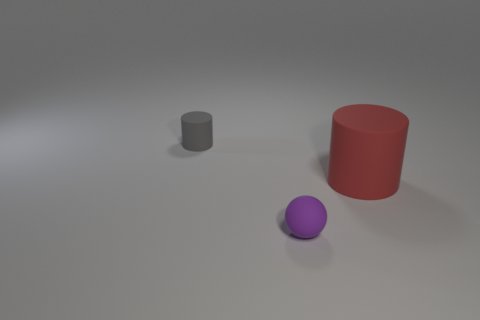Are there fewer big gray cylinders than matte balls?
Your response must be concise. Yes. Is the material of the tiny object left of the sphere the same as the large cylinder?
Give a very brief answer. Yes. How many cylinders are purple rubber things or big red objects?
Give a very brief answer. 1. There is a rubber object that is both behind the purple rubber ball and in front of the gray thing; what shape is it?
Make the answer very short. Cylinder. There is a rubber cylinder to the right of the tiny object that is right of the small object that is behind the tiny purple rubber sphere; what is its color?
Give a very brief answer. Red. Is the number of matte things that are in front of the small purple object less than the number of red things?
Your response must be concise. Yes. There is a small object in front of the tiny gray matte object; does it have the same shape as the tiny rubber thing behind the small purple thing?
Give a very brief answer. No. What number of things are either matte cylinders in front of the tiny gray matte cylinder or gray cylinders?
Offer a very short reply. 2. There is a small thing in front of the tiny matte object behind the large matte cylinder; is there a purple matte sphere that is in front of it?
Provide a short and direct response. No. Is the number of things that are in front of the red thing less than the number of tiny purple matte objects that are left of the small purple object?
Provide a succinct answer. No. 